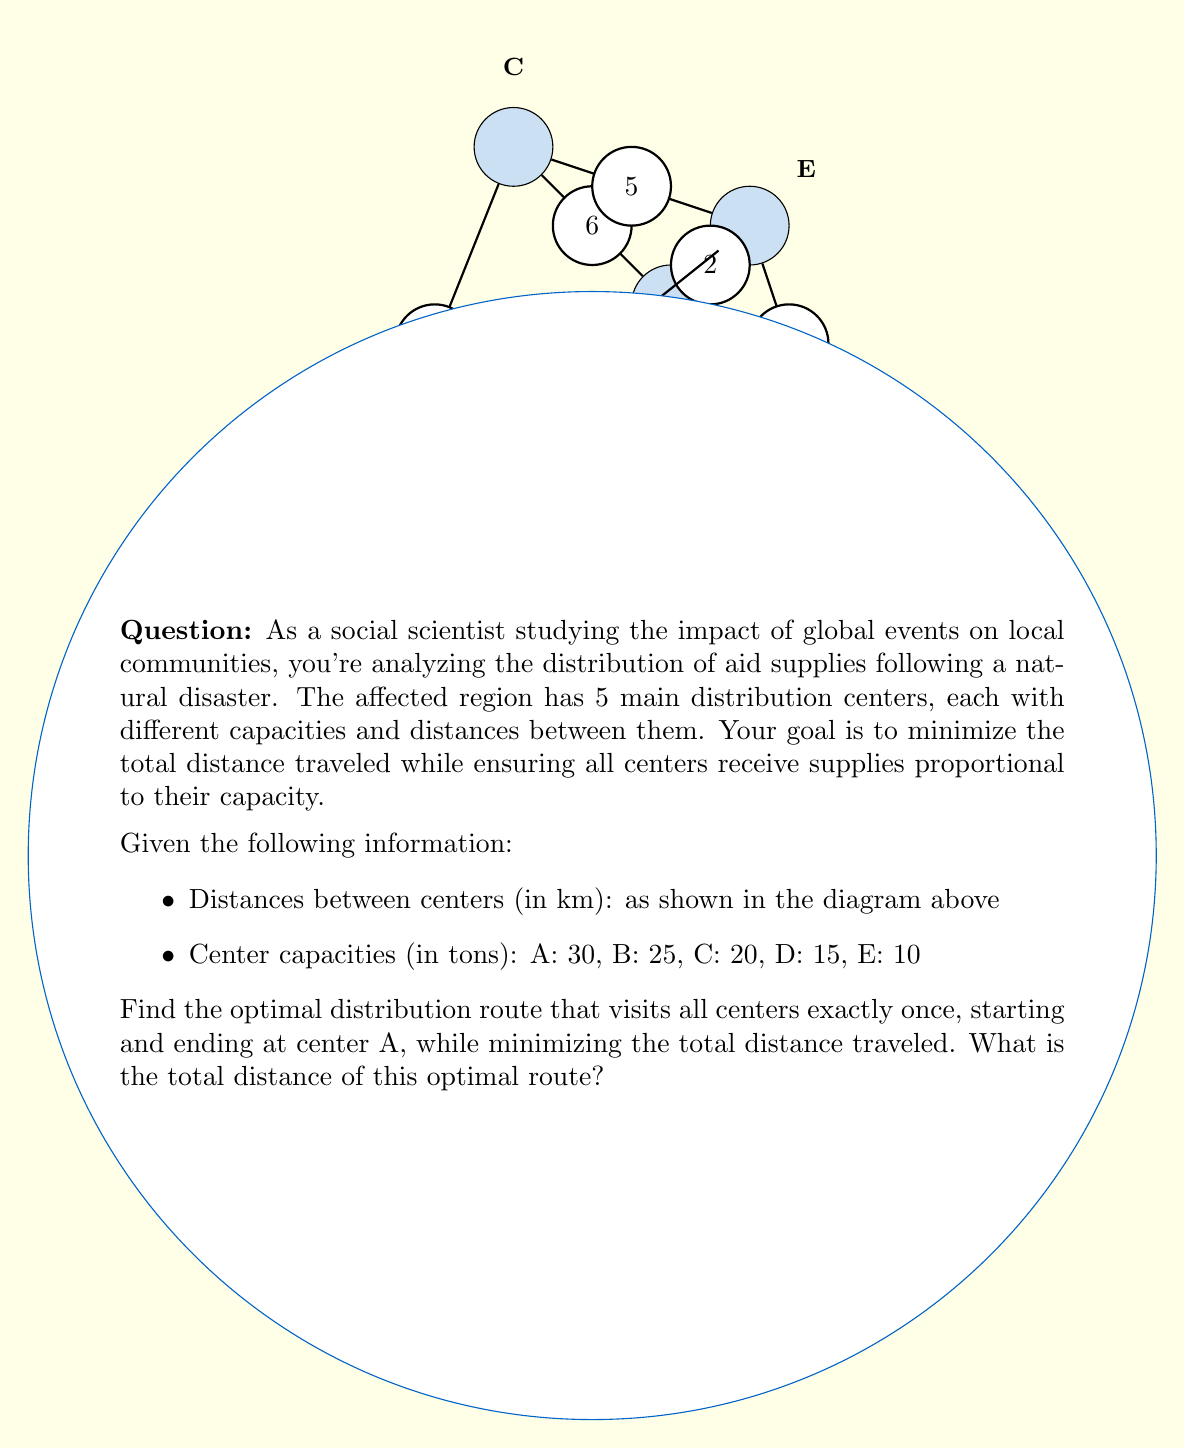Could you help me with this problem? To solve this problem, we need to use the Traveling Salesman Problem (TSP) approach, which is an optimization problem in graph theory. Given the small number of nodes, we can use a brute-force method to find the optimal solution.

Step 1: List all possible routes starting and ending at A.
There are (5-1)! = 24 possible routes.

Step 2: Calculate the total distance for each route.
For example:
A-B-C-D-E-A = 5 + 6 + 3 + 4 + 7 = 25 km
A-B-C-E-D-A = 5 + 6 + 5 + 4 + 7 = 27 km
...

Step 3: Compare all routes and find the one with the minimum total distance.
After calculating all routes, we find that the optimal route is:

A-C-E-B-D-A

Step 4: Calculate the total distance of the optimal route.
A to C: 4 km
C to E: 5 km
E to B: 2 km
B to D: 3 km
D to A: 7 km

Total distance = 4 + 5 + 2 + 3 + 7 = 21 km

Therefore, the optimal distribution route that visits all centers exactly once, starting and ending at center A, while minimizing the total distance traveled is A-C-E-B-D-A, with a total distance of 21 km.
Answer: 21 km 